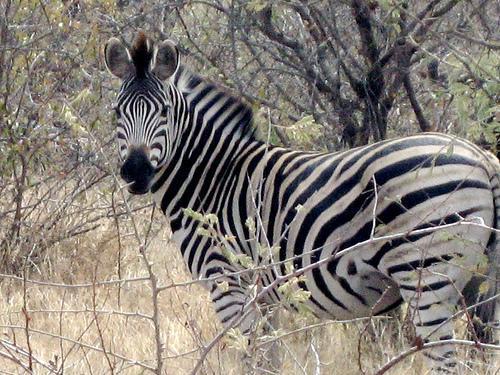How many ears does this animal have?
Give a very brief answer. 2. How many zebras have black ears?
Give a very brief answer. 1. How many zebras are there?
Give a very brief answer. 1. 